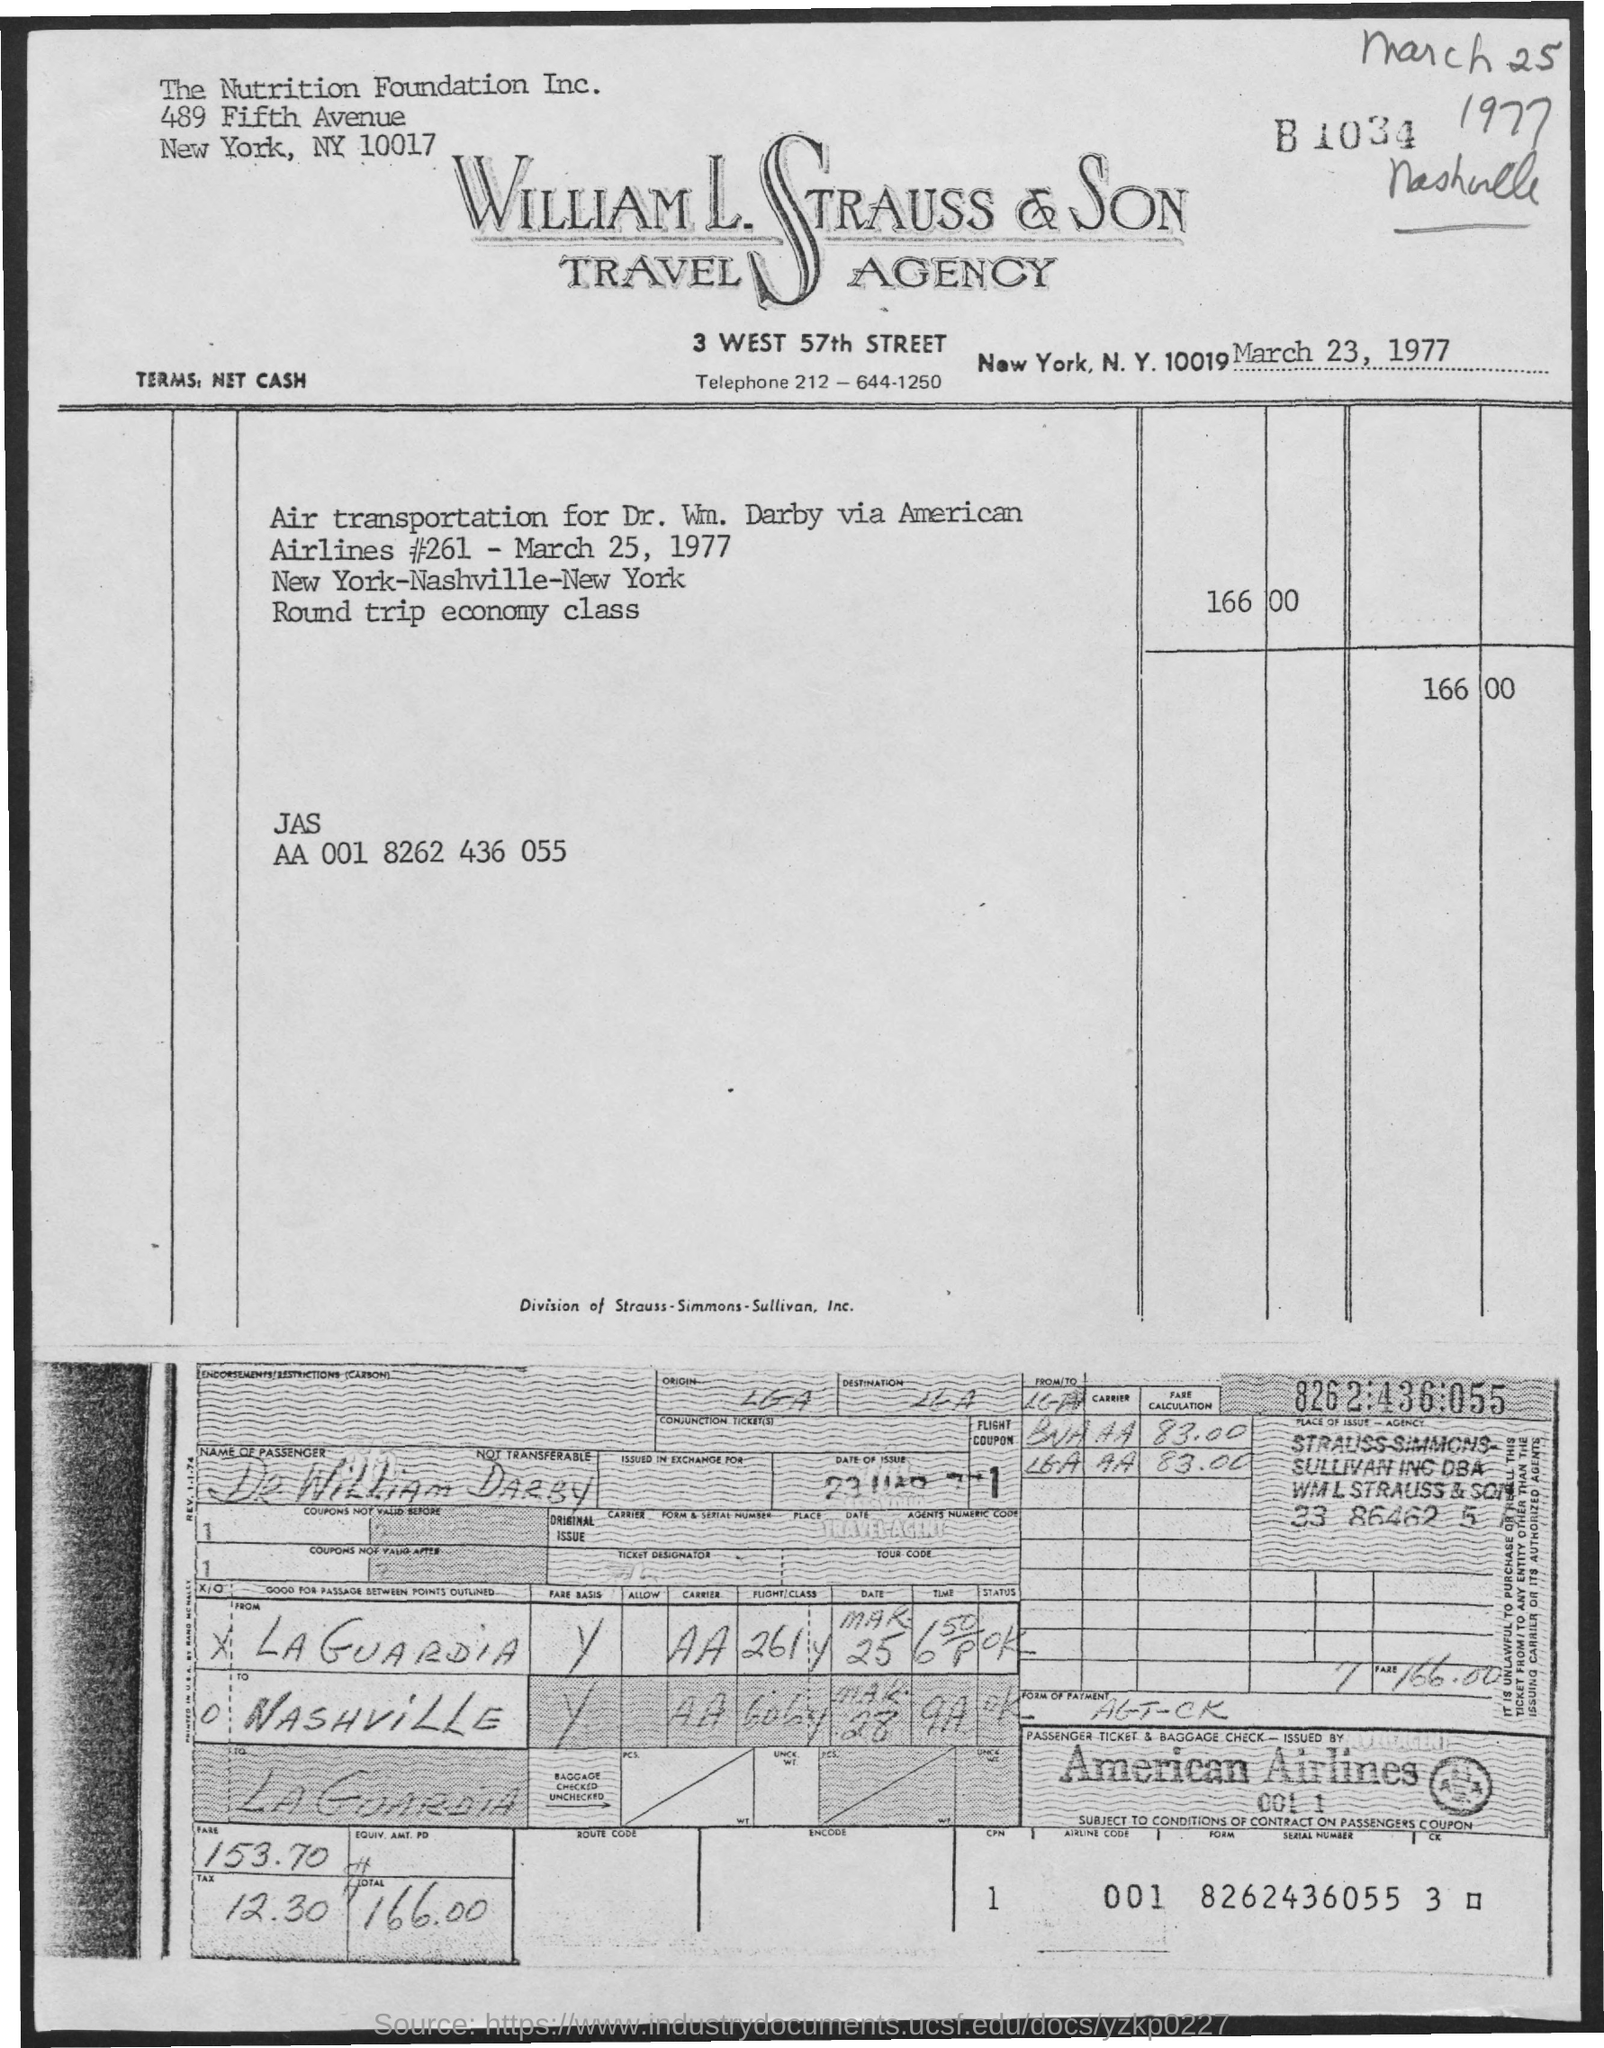What is the name of the Travel Agency?
Provide a succinct answer. William l. strauss & son travel agency. Who has travelled?
Keep it short and to the point. DR. WILLIAM DARBY. 